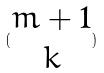<formula> <loc_0><loc_0><loc_500><loc_500>( \begin{matrix} m + 1 \\ k \end{matrix} )</formula> 